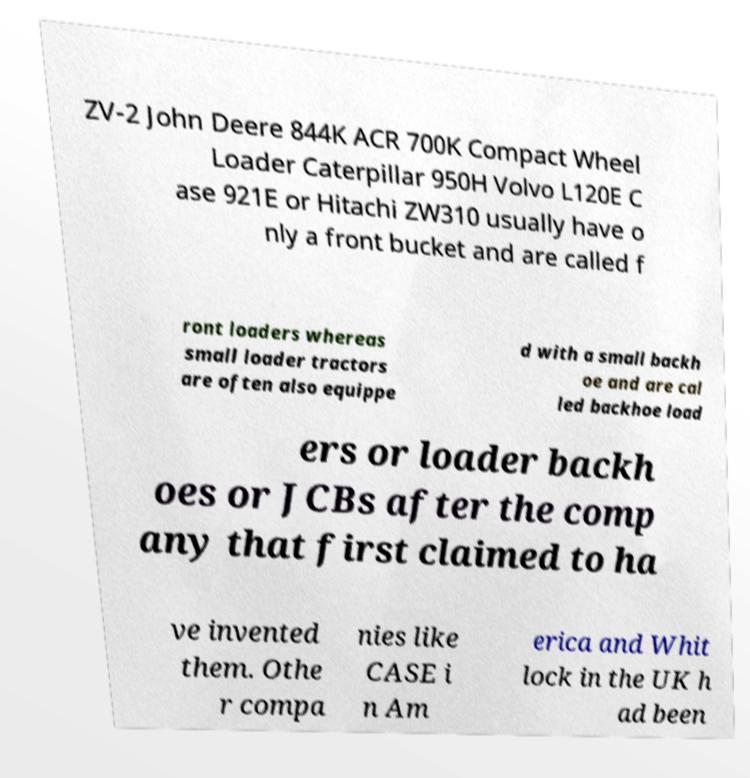For documentation purposes, I need the text within this image transcribed. Could you provide that? ZV-2 John Deere 844K ACR 700K Compact Wheel Loader Caterpillar 950H Volvo L120E C ase 921E or Hitachi ZW310 usually have o nly a front bucket and are called f ront loaders whereas small loader tractors are often also equippe d with a small backh oe and are cal led backhoe load ers or loader backh oes or JCBs after the comp any that first claimed to ha ve invented them. Othe r compa nies like CASE i n Am erica and Whit lock in the UK h ad been 